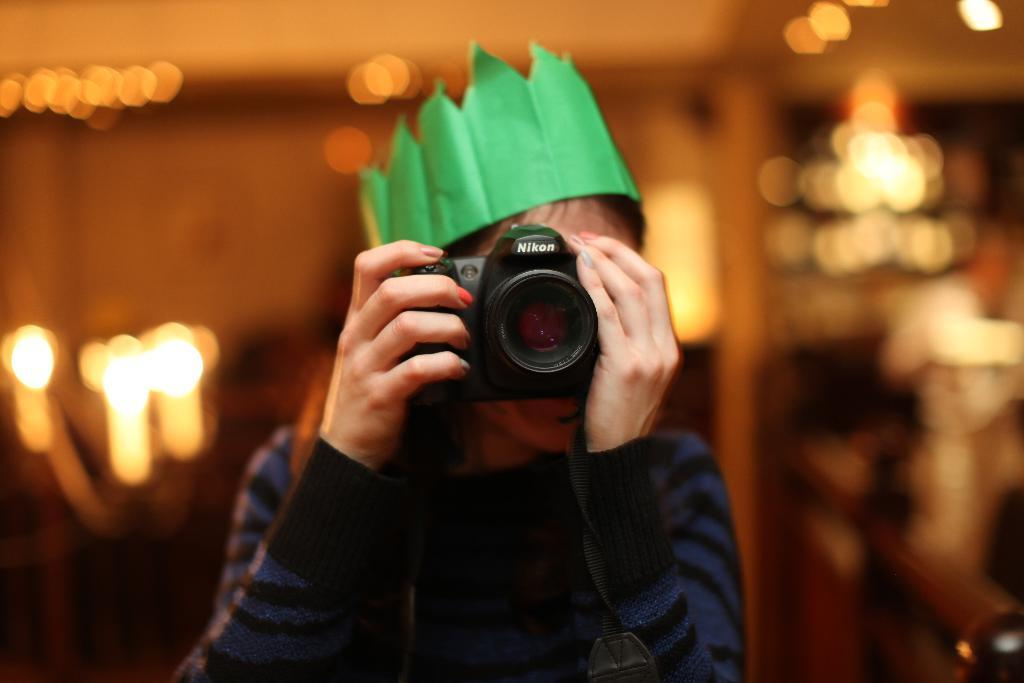What is the main subject of the image? There is a person in the image. What is the person doing in the image? The person is standing and holding a camera. Can you describe the background of the image? The background of the image is blurred. What else can be seen in the image besides the person? There are visible lights in the image. What type of straw is the person using to take a holiday in the image? There is no straw or holiday mentioned or depicted in the image. 